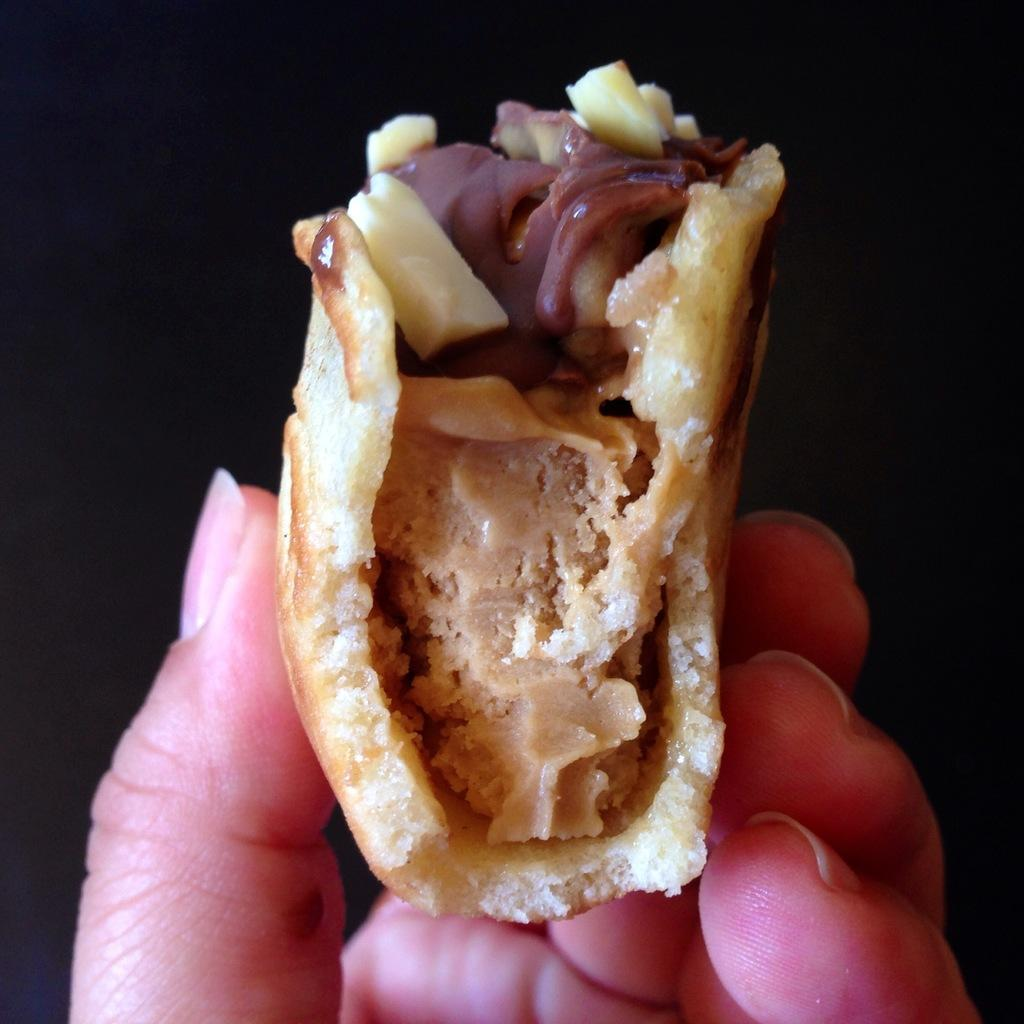What is the main subject of the image? There is a person in the image. What is the person doing in the image? The person is holding food. What is the color of the background in the image? The background in the image is black. What type of impulse can be seen affecting the person's eyes in the image? There is no impulse or any indication of an impulse affecting the person's eyes in the image. 